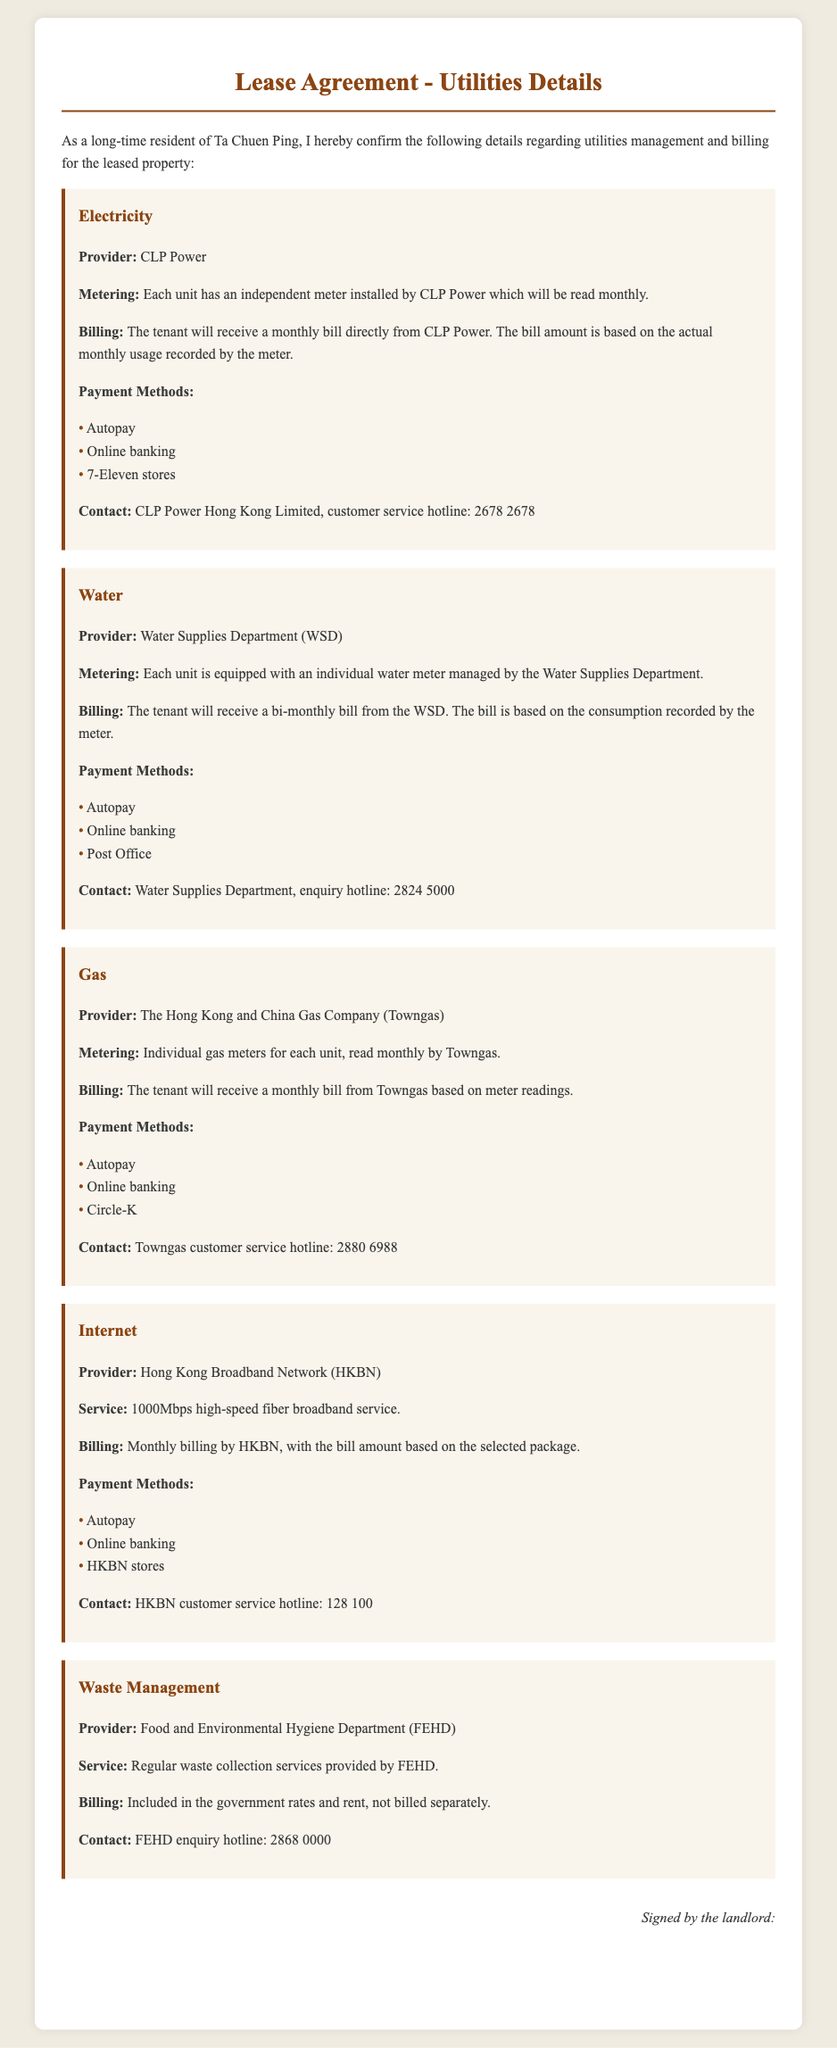What is the electricity provider? The electricity provider is mentioned in the section on Electricity details as CLP Power.
Answer: CLP Power How often is the electricity bill issued? The billing frequency for electricity is stated in the document as monthly.
Answer: Monthly What payment methods are available for water? The document lists specific payment methods available for the water bill, including Autopay, Online banking, and Post Office.
Answer: Autopay, Online banking, Post Office What is the internet service speed provided? The document specifies the internet service speed as 1000Mbps, which can be found in the Internet section.
Answer: 1000Mbps Who manages waste collection? The section on Waste Management specifies that the Food and Environmental Hygiene Department (FEHD) provides this service.
Answer: Food and Environmental Hygiene Department (FEHD) How often is the water bill issued? The billing frequency for water is described as bi-monthly in the document.
Answer: Bi-monthly What is the contact number for Towngas? The contact number for Towngas is mentioned in the Gas utility section as 2880 6988.
Answer: 2880 6988 Are waste management services billed separately? The document indicates that waste management costs are included in the government rates and rent, making it not billed separately.
Answer: Not billed separately Which company provides the internet service? The internet provider is specified as Hong Kong Broadband Network (HKBN) in the Internet section.
Answer: Hong Kong Broadband Network (HKBN) 